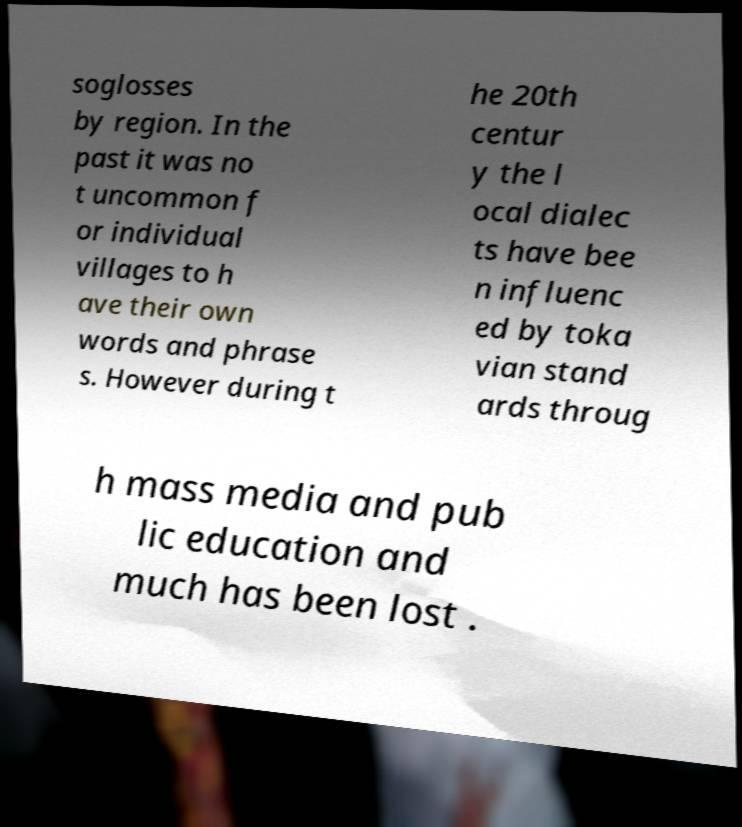Please identify and transcribe the text found in this image. soglosses by region. In the past it was no t uncommon f or individual villages to h ave their own words and phrase s. However during t he 20th centur y the l ocal dialec ts have bee n influenc ed by toka vian stand ards throug h mass media and pub lic education and much has been lost . 